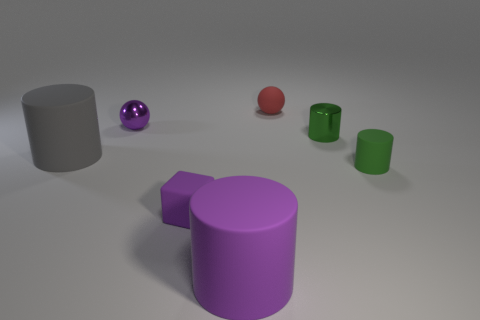Add 2 green matte cylinders. How many objects exist? 9 Subtract all blocks. How many objects are left? 6 Subtract 0 yellow balls. How many objects are left? 7 Subtract all big green rubber balls. Subtract all green matte cylinders. How many objects are left? 6 Add 5 purple metallic balls. How many purple metallic balls are left? 6 Add 7 large purple matte cylinders. How many large purple matte cylinders exist? 8 